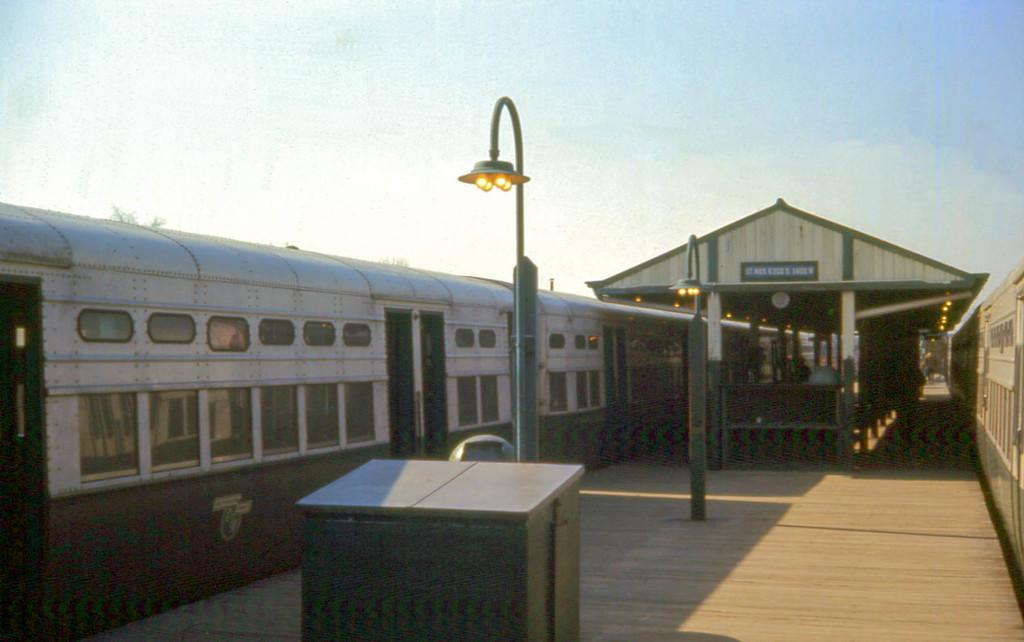What object made of wood can be seen in the image? There is a wooden box in the image. What type of structures are present to provide light in the image? There are light poles in the image. What surface is present for people or objects to stand on in the image? There is a platform in the image. What mode of transportation can be seen on either side of the image? Trains are visible on either side of the image. What can be seen in the background of the image, far away from the other elements? The sky is plain in the background of the image. How much sugar is being transported by the trains in the image? There is no information about sugar or its transportation in the image; it only shows trains. What is located on the top of the wooden box in the image? There is no information about anything being on top of the wooden box in the image; it only shows the box itself. 